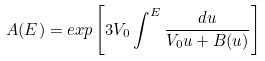<formula> <loc_0><loc_0><loc_500><loc_500>A ( E ) = e x p \left [ 3 V _ { 0 } \int ^ { E } \frac { d u } { V _ { 0 } u + B ( u ) } \right ]</formula> 